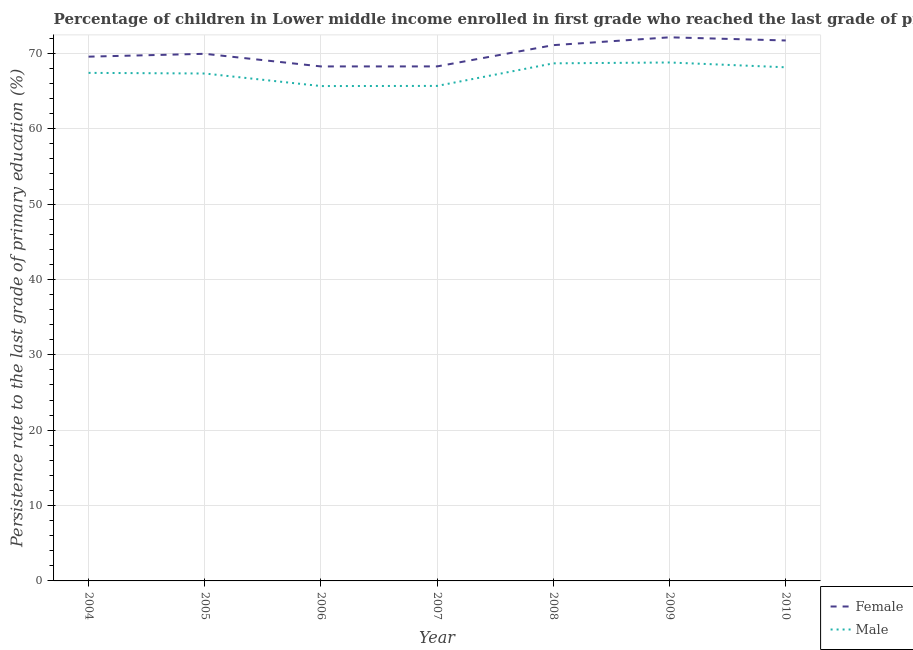How many different coloured lines are there?
Offer a terse response. 2. Does the line corresponding to persistence rate of male students intersect with the line corresponding to persistence rate of female students?
Your answer should be very brief. No. What is the persistence rate of female students in 2005?
Keep it short and to the point. 69.94. Across all years, what is the maximum persistence rate of male students?
Your answer should be very brief. 68.79. Across all years, what is the minimum persistence rate of male students?
Your answer should be very brief. 65.66. What is the total persistence rate of female students in the graph?
Offer a very short reply. 490.98. What is the difference between the persistence rate of female students in 2006 and that in 2009?
Keep it short and to the point. -3.86. What is the difference between the persistence rate of female students in 2009 and the persistence rate of male students in 2006?
Your answer should be compact. 6.47. What is the average persistence rate of male students per year?
Your answer should be compact. 67.39. In the year 2010, what is the difference between the persistence rate of male students and persistence rate of female students?
Your answer should be very brief. -3.56. In how many years, is the persistence rate of female students greater than 8 %?
Provide a short and direct response. 7. What is the ratio of the persistence rate of male students in 2004 to that in 2006?
Your answer should be compact. 1.03. Is the persistence rate of male students in 2006 less than that in 2010?
Your answer should be compact. Yes. What is the difference between the highest and the second highest persistence rate of male students?
Make the answer very short. 0.11. What is the difference between the highest and the lowest persistence rate of male students?
Your answer should be very brief. 3.13. In how many years, is the persistence rate of female students greater than the average persistence rate of female students taken over all years?
Keep it short and to the point. 3. Is the persistence rate of male students strictly greater than the persistence rate of female students over the years?
Keep it short and to the point. No. Are the values on the major ticks of Y-axis written in scientific E-notation?
Ensure brevity in your answer.  No. How many legend labels are there?
Keep it short and to the point. 2. How are the legend labels stacked?
Keep it short and to the point. Vertical. What is the title of the graph?
Offer a terse response. Percentage of children in Lower middle income enrolled in first grade who reached the last grade of primary education. Does "Rural Population" appear as one of the legend labels in the graph?
Your response must be concise. No. What is the label or title of the X-axis?
Ensure brevity in your answer.  Year. What is the label or title of the Y-axis?
Offer a very short reply. Persistence rate to the last grade of primary education (%). What is the Persistence rate to the last grade of primary education (%) in Female in 2004?
Your response must be concise. 69.56. What is the Persistence rate to the last grade of primary education (%) of Male in 2004?
Your answer should be compact. 67.41. What is the Persistence rate to the last grade of primary education (%) of Female in 2005?
Keep it short and to the point. 69.94. What is the Persistence rate to the last grade of primary education (%) in Male in 2005?
Keep it short and to the point. 67.33. What is the Persistence rate to the last grade of primary education (%) in Female in 2006?
Provide a succinct answer. 68.27. What is the Persistence rate to the last grade of primary education (%) in Male in 2006?
Provide a succinct answer. 65.66. What is the Persistence rate to the last grade of primary education (%) of Female in 2007?
Your answer should be very brief. 68.27. What is the Persistence rate to the last grade of primary education (%) of Male in 2007?
Make the answer very short. 65.68. What is the Persistence rate to the last grade of primary education (%) of Female in 2008?
Ensure brevity in your answer.  71.09. What is the Persistence rate to the last grade of primary education (%) in Male in 2008?
Ensure brevity in your answer.  68.68. What is the Persistence rate to the last grade of primary education (%) of Female in 2009?
Offer a terse response. 72.13. What is the Persistence rate to the last grade of primary education (%) of Male in 2009?
Give a very brief answer. 68.79. What is the Persistence rate to the last grade of primary education (%) of Female in 2010?
Provide a succinct answer. 71.71. What is the Persistence rate to the last grade of primary education (%) in Male in 2010?
Ensure brevity in your answer.  68.15. Across all years, what is the maximum Persistence rate to the last grade of primary education (%) in Female?
Offer a very short reply. 72.13. Across all years, what is the maximum Persistence rate to the last grade of primary education (%) of Male?
Your answer should be compact. 68.79. Across all years, what is the minimum Persistence rate to the last grade of primary education (%) in Female?
Provide a short and direct response. 68.27. Across all years, what is the minimum Persistence rate to the last grade of primary education (%) of Male?
Provide a short and direct response. 65.66. What is the total Persistence rate to the last grade of primary education (%) in Female in the graph?
Provide a short and direct response. 490.98. What is the total Persistence rate to the last grade of primary education (%) in Male in the graph?
Give a very brief answer. 471.7. What is the difference between the Persistence rate to the last grade of primary education (%) of Female in 2004 and that in 2005?
Offer a terse response. -0.38. What is the difference between the Persistence rate to the last grade of primary education (%) of Male in 2004 and that in 2005?
Offer a terse response. 0.08. What is the difference between the Persistence rate to the last grade of primary education (%) in Female in 2004 and that in 2006?
Your answer should be compact. 1.3. What is the difference between the Persistence rate to the last grade of primary education (%) of Male in 2004 and that in 2006?
Your response must be concise. 1.75. What is the difference between the Persistence rate to the last grade of primary education (%) in Female in 2004 and that in 2007?
Offer a terse response. 1.29. What is the difference between the Persistence rate to the last grade of primary education (%) of Male in 2004 and that in 2007?
Provide a succinct answer. 1.73. What is the difference between the Persistence rate to the last grade of primary education (%) in Female in 2004 and that in 2008?
Offer a very short reply. -1.53. What is the difference between the Persistence rate to the last grade of primary education (%) of Male in 2004 and that in 2008?
Ensure brevity in your answer.  -1.26. What is the difference between the Persistence rate to the last grade of primary education (%) of Female in 2004 and that in 2009?
Give a very brief answer. -2.57. What is the difference between the Persistence rate to the last grade of primary education (%) in Male in 2004 and that in 2009?
Keep it short and to the point. -1.38. What is the difference between the Persistence rate to the last grade of primary education (%) in Female in 2004 and that in 2010?
Keep it short and to the point. -2.15. What is the difference between the Persistence rate to the last grade of primary education (%) of Male in 2004 and that in 2010?
Your response must be concise. -0.74. What is the difference between the Persistence rate to the last grade of primary education (%) in Female in 2005 and that in 2006?
Keep it short and to the point. 1.68. What is the difference between the Persistence rate to the last grade of primary education (%) in Male in 2005 and that in 2006?
Your response must be concise. 1.67. What is the difference between the Persistence rate to the last grade of primary education (%) of Female in 2005 and that in 2007?
Offer a very short reply. 1.67. What is the difference between the Persistence rate to the last grade of primary education (%) of Male in 2005 and that in 2007?
Make the answer very short. 1.65. What is the difference between the Persistence rate to the last grade of primary education (%) of Female in 2005 and that in 2008?
Offer a very short reply. -1.15. What is the difference between the Persistence rate to the last grade of primary education (%) of Male in 2005 and that in 2008?
Ensure brevity in your answer.  -1.35. What is the difference between the Persistence rate to the last grade of primary education (%) of Female in 2005 and that in 2009?
Keep it short and to the point. -2.19. What is the difference between the Persistence rate to the last grade of primary education (%) in Male in 2005 and that in 2009?
Your answer should be compact. -1.46. What is the difference between the Persistence rate to the last grade of primary education (%) in Female in 2005 and that in 2010?
Your answer should be compact. -1.77. What is the difference between the Persistence rate to the last grade of primary education (%) of Male in 2005 and that in 2010?
Your response must be concise. -0.82. What is the difference between the Persistence rate to the last grade of primary education (%) in Female in 2006 and that in 2007?
Offer a terse response. -0. What is the difference between the Persistence rate to the last grade of primary education (%) of Male in 2006 and that in 2007?
Offer a very short reply. -0.02. What is the difference between the Persistence rate to the last grade of primary education (%) of Female in 2006 and that in 2008?
Keep it short and to the point. -2.83. What is the difference between the Persistence rate to the last grade of primary education (%) in Male in 2006 and that in 2008?
Provide a short and direct response. -3.01. What is the difference between the Persistence rate to the last grade of primary education (%) in Female in 2006 and that in 2009?
Offer a very short reply. -3.86. What is the difference between the Persistence rate to the last grade of primary education (%) of Male in 2006 and that in 2009?
Provide a short and direct response. -3.13. What is the difference between the Persistence rate to the last grade of primary education (%) in Female in 2006 and that in 2010?
Make the answer very short. -3.44. What is the difference between the Persistence rate to the last grade of primary education (%) in Male in 2006 and that in 2010?
Keep it short and to the point. -2.49. What is the difference between the Persistence rate to the last grade of primary education (%) in Female in 2007 and that in 2008?
Offer a terse response. -2.82. What is the difference between the Persistence rate to the last grade of primary education (%) in Male in 2007 and that in 2008?
Your answer should be compact. -2.99. What is the difference between the Persistence rate to the last grade of primary education (%) of Female in 2007 and that in 2009?
Provide a succinct answer. -3.86. What is the difference between the Persistence rate to the last grade of primary education (%) of Male in 2007 and that in 2009?
Keep it short and to the point. -3.11. What is the difference between the Persistence rate to the last grade of primary education (%) of Female in 2007 and that in 2010?
Offer a very short reply. -3.44. What is the difference between the Persistence rate to the last grade of primary education (%) of Male in 2007 and that in 2010?
Provide a short and direct response. -2.47. What is the difference between the Persistence rate to the last grade of primary education (%) of Female in 2008 and that in 2009?
Make the answer very short. -1.04. What is the difference between the Persistence rate to the last grade of primary education (%) of Male in 2008 and that in 2009?
Offer a terse response. -0.11. What is the difference between the Persistence rate to the last grade of primary education (%) in Female in 2008 and that in 2010?
Provide a succinct answer. -0.62. What is the difference between the Persistence rate to the last grade of primary education (%) of Male in 2008 and that in 2010?
Provide a succinct answer. 0.52. What is the difference between the Persistence rate to the last grade of primary education (%) of Female in 2009 and that in 2010?
Give a very brief answer. 0.42. What is the difference between the Persistence rate to the last grade of primary education (%) in Male in 2009 and that in 2010?
Give a very brief answer. 0.64. What is the difference between the Persistence rate to the last grade of primary education (%) in Female in 2004 and the Persistence rate to the last grade of primary education (%) in Male in 2005?
Your answer should be compact. 2.24. What is the difference between the Persistence rate to the last grade of primary education (%) of Female in 2004 and the Persistence rate to the last grade of primary education (%) of Male in 2006?
Offer a very short reply. 3.9. What is the difference between the Persistence rate to the last grade of primary education (%) in Female in 2004 and the Persistence rate to the last grade of primary education (%) in Male in 2007?
Offer a very short reply. 3.88. What is the difference between the Persistence rate to the last grade of primary education (%) of Female in 2004 and the Persistence rate to the last grade of primary education (%) of Male in 2008?
Give a very brief answer. 0.89. What is the difference between the Persistence rate to the last grade of primary education (%) of Female in 2004 and the Persistence rate to the last grade of primary education (%) of Male in 2009?
Your answer should be compact. 0.77. What is the difference between the Persistence rate to the last grade of primary education (%) of Female in 2004 and the Persistence rate to the last grade of primary education (%) of Male in 2010?
Make the answer very short. 1.41. What is the difference between the Persistence rate to the last grade of primary education (%) in Female in 2005 and the Persistence rate to the last grade of primary education (%) in Male in 2006?
Offer a very short reply. 4.28. What is the difference between the Persistence rate to the last grade of primary education (%) of Female in 2005 and the Persistence rate to the last grade of primary education (%) of Male in 2007?
Make the answer very short. 4.26. What is the difference between the Persistence rate to the last grade of primary education (%) of Female in 2005 and the Persistence rate to the last grade of primary education (%) of Male in 2008?
Offer a terse response. 1.27. What is the difference between the Persistence rate to the last grade of primary education (%) in Female in 2005 and the Persistence rate to the last grade of primary education (%) in Male in 2009?
Offer a very short reply. 1.15. What is the difference between the Persistence rate to the last grade of primary education (%) of Female in 2005 and the Persistence rate to the last grade of primary education (%) of Male in 2010?
Provide a short and direct response. 1.79. What is the difference between the Persistence rate to the last grade of primary education (%) in Female in 2006 and the Persistence rate to the last grade of primary education (%) in Male in 2007?
Provide a succinct answer. 2.58. What is the difference between the Persistence rate to the last grade of primary education (%) in Female in 2006 and the Persistence rate to the last grade of primary education (%) in Male in 2008?
Ensure brevity in your answer.  -0.41. What is the difference between the Persistence rate to the last grade of primary education (%) in Female in 2006 and the Persistence rate to the last grade of primary education (%) in Male in 2009?
Provide a succinct answer. -0.52. What is the difference between the Persistence rate to the last grade of primary education (%) in Female in 2006 and the Persistence rate to the last grade of primary education (%) in Male in 2010?
Offer a very short reply. 0.11. What is the difference between the Persistence rate to the last grade of primary education (%) in Female in 2007 and the Persistence rate to the last grade of primary education (%) in Male in 2008?
Offer a very short reply. -0.41. What is the difference between the Persistence rate to the last grade of primary education (%) of Female in 2007 and the Persistence rate to the last grade of primary education (%) of Male in 2009?
Ensure brevity in your answer.  -0.52. What is the difference between the Persistence rate to the last grade of primary education (%) of Female in 2007 and the Persistence rate to the last grade of primary education (%) of Male in 2010?
Offer a terse response. 0.12. What is the difference between the Persistence rate to the last grade of primary education (%) in Female in 2008 and the Persistence rate to the last grade of primary education (%) in Male in 2009?
Provide a succinct answer. 2.3. What is the difference between the Persistence rate to the last grade of primary education (%) in Female in 2008 and the Persistence rate to the last grade of primary education (%) in Male in 2010?
Provide a short and direct response. 2.94. What is the difference between the Persistence rate to the last grade of primary education (%) in Female in 2009 and the Persistence rate to the last grade of primary education (%) in Male in 2010?
Your answer should be compact. 3.98. What is the average Persistence rate to the last grade of primary education (%) in Female per year?
Provide a succinct answer. 70.14. What is the average Persistence rate to the last grade of primary education (%) of Male per year?
Your answer should be compact. 67.39. In the year 2004, what is the difference between the Persistence rate to the last grade of primary education (%) in Female and Persistence rate to the last grade of primary education (%) in Male?
Keep it short and to the point. 2.15. In the year 2005, what is the difference between the Persistence rate to the last grade of primary education (%) in Female and Persistence rate to the last grade of primary education (%) in Male?
Give a very brief answer. 2.61. In the year 2006, what is the difference between the Persistence rate to the last grade of primary education (%) in Female and Persistence rate to the last grade of primary education (%) in Male?
Your answer should be very brief. 2.6. In the year 2007, what is the difference between the Persistence rate to the last grade of primary education (%) in Female and Persistence rate to the last grade of primary education (%) in Male?
Make the answer very short. 2.59. In the year 2008, what is the difference between the Persistence rate to the last grade of primary education (%) in Female and Persistence rate to the last grade of primary education (%) in Male?
Your answer should be very brief. 2.42. In the year 2009, what is the difference between the Persistence rate to the last grade of primary education (%) in Female and Persistence rate to the last grade of primary education (%) in Male?
Keep it short and to the point. 3.34. In the year 2010, what is the difference between the Persistence rate to the last grade of primary education (%) of Female and Persistence rate to the last grade of primary education (%) of Male?
Ensure brevity in your answer.  3.56. What is the ratio of the Persistence rate to the last grade of primary education (%) of Female in 2004 to that in 2005?
Give a very brief answer. 0.99. What is the ratio of the Persistence rate to the last grade of primary education (%) in Female in 2004 to that in 2006?
Your answer should be very brief. 1.02. What is the ratio of the Persistence rate to the last grade of primary education (%) in Male in 2004 to that in 2006?
Your answer should be compact. 1.03. What is the ratio of the Persistence rate to the last grade of primary education (%) of Male in 2004 to that in 2007?
Provide a short and direct response. 1.03. What is the ratio of the Persistence rate to the last grade of primary education (%) in Female in 2004 to that in 2008?
Your answer should be very brief. 0.98. What is the ratio of the Persistence rate to the last grade of primary education (%) of Male in 2004 to that in 2008?
Make the answer very short. 0.98. What is the ratio of the Persistence rate to the last grade of primary education (%) in Female in 2004 to that in 2009?
Your answer should be very brief. 0.96. What is the ratio of the Persistence rate to the last grade of primary education (%) of Male in 2004 to that in 2009?
Provide a succinct answer. 0.98. What is the ratio of the Persistence rate to the last grade of primary education (%) in Male in 2004 to that in 2010?
Provide a succinct answer. 0.99. What is the ratio of the Persistence rate to the last grade of primary education (%) of Female in 2005 to that in 2006?
Keep it short and to the point. 1.02. What is the ratio of the Persistence rate to the last grade of primary education (%) of Male in 2005 to that in 2006?
Provide a short and direct response. 1.03. What is the ratio of the Persistence rate to the last grade of primary education (%) of Female in 2005 to that in 2007?
Offer a very short reply. 1.02. What is the ratio of the Persistence rate to the last grade of primary education (%) in Male in 2005 to that in 2007?
Provide a short and direct response. 1.03. What is the ratio of the Persistence rate to the last grade of primary education (%) in Female in 2005 to that in 2008?
Your response must be concise. 0.98. What is the ratio of the Persistence rate to the last grade of primary education (%) in Male in 2005 to that in 2008?
Your answer should be compact. 0.98. What is the ratio of the Persistence rate to the last grade of primary education (%) of Female in 2005 to that in 2009?
Your answer should be very brief. 0.97. What is the ratio of the Persistence rate to the last grade of primary education (%) of Male in 2005 to that in 2009?
Offer a very short reply. 0.98. What is the ratio of the Persistence rate to the last grade of primary education (%) in Female in 2005 to that in 2010?
Offer a terse response. 0.98. What is the ratio of the Persistence rate to the last grade of primary education (%) of Male in 2005 to that in 2010?
Make the answer very short. 0.99. What is the ratio of the Persistence rate to the last grade of primary education (%) of Female in 2006 to that in 2007?
Ensure brevity in your answer.  1. What is the ratio of the Persistence rate to the last grade of primary education (%) in Female in 2006 to that in 2008?
Your answer should be very brief. 0.96. What is the ratio of the Persistence rate to the last grade of primary education (%) of Male in 2006 to that in 2008?
Make the answer very short. 0.96. What is the ratio of the Persistence rate to the last grade of primary education (%) in Female in 2006 to that in 2009?
Offer a very short reply. 0.95. What is the ratio of the Persistence rate to the last grade of primary education (%) in Male in 2006 to that in 2009?
Give a very brief answer. 0.95. What is the ratio of the Persistence rate to the last grade of primary education (%) of Male in 2006 to that in 2010?
Offer a very short reply. 0.96. What is the ratio of the Persistence rate to the last grade of primary education (%) in Female in 2007 to that in 2008?
Offer a terse response. 0.96. What is the ratio of the Persistence rate to the last grade of primary education (%) of Male in 2007 to that in 2008?
Ensure brevity in your answer.  0.96. What is the ratio of the Persistence rate to the last grade of primary education (%) in Female in 2007 to that in 2009?
Make the answer very short. 0.95. What is the ratio of the Persistence rate to the last grade of primary education (%) of Male in 2007 to that in 2009?
Your response must be concise. 0.95. What is the ratio of the Persistence rate to the last grade of primary education (%) in Male in 2007 to that in 2010?
Keep it short and to the point. 0.96. What is the ratio of the Persistence rate to the last grade of primary education (%) in Female in 2008 to that in 2009?
Your answer should be very brief. 0.99. What is the ratio of the Persistence rate to the last grade of primary education (%) of Male in 2008 to that in 2009?
Offer a terse response. 1. What is the ratio of the Persistence rate to the last grade of primary education (%) in Male in 2008 to that in 2010?
Give a very brief answer. 1.01. What is the ratio of the Persistence rate to the last grade of primary education (%) in Male in 2009 to that in 2010?
Your answer should be compact. 1.01. What is the difference between the highest and the second highest Persistence rate to the last grade of primary education (%) of Female?
Your response must be concise. 0.42. What is the difference between the highest and the second highest Persistence rate to the last grade of primary education (%) in Male?
Make the answer very short. 0.11. What is the difference between the highest and the lowest Persistence rate to the last grade of primary education (%) of Female?
Provide a succinct answer. 3.86. What is the difference between the highest and the lowest Persistence rate to the last grade of primary education (%) of Male?
Offer a terse response. 3.13. 